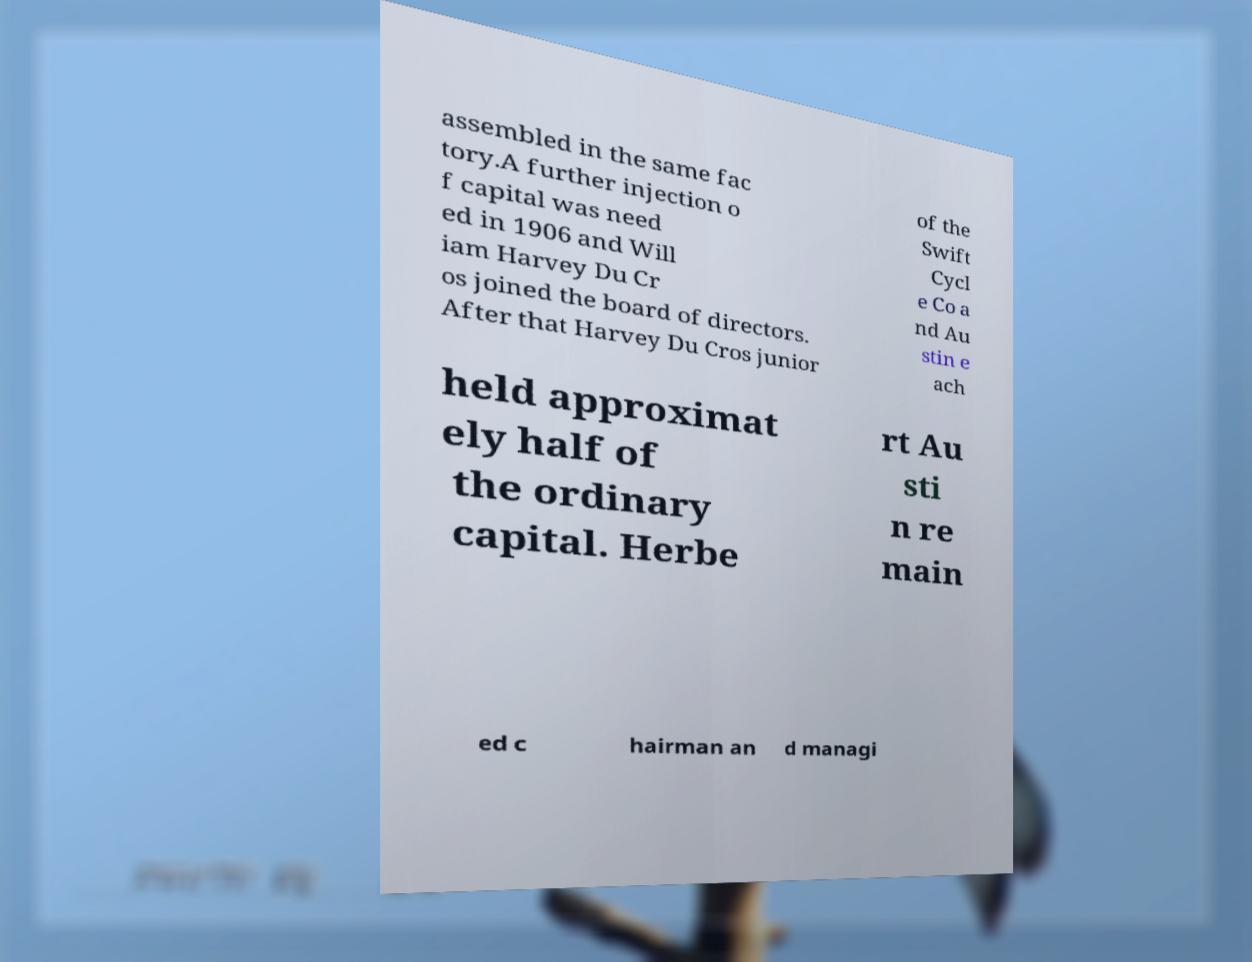What messages or text are displayed in this image? I need them in a readable, typed format. assembled in the same fac tory.A further injection o f capital was need ed in 1906 and Will iam Harvey Du Cr os joined the board of directors. After that Harvey Du Cros junior of the Swift Cycl e Co a nd Au stin e ach held approximat ely half of the ordinary capital. Herbe rt Au sti n re main ed c hairman an d managi 